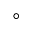Convert formula to latex. <formula><loc_0><loc_0><loc_500><loc_500>^ { \circ }</formula> 